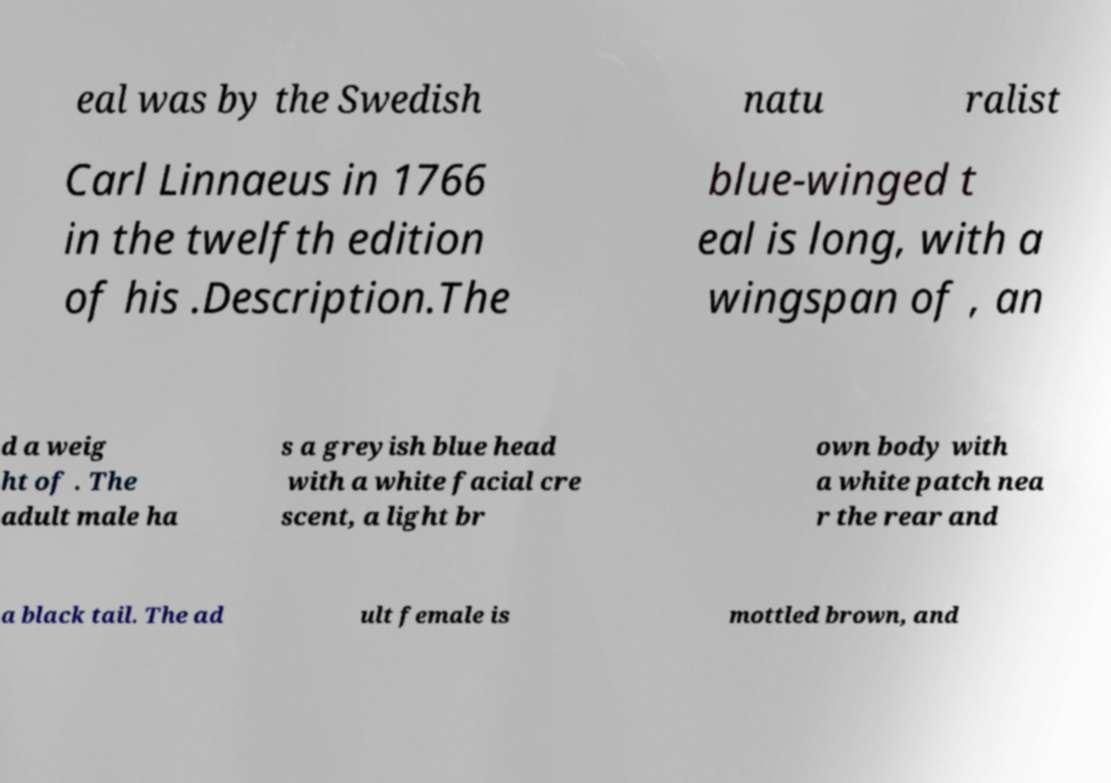Could you extract and type out the text from this image? eal was by the Swedish natu ralist Carl Linnaeus in 1766 in the twelfth edition of his .Description.The blue-winged t eal is long, with a wingspan of , an d a weig ht of . The adult male ha s a greyish blue head with a white facial cre scent, a light br own body with a white patch nea r the rear and a black tail. The ad ult female is mottled brown, and 